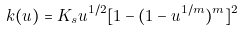<formula> <loc_0><loc_0><loc_500><loc_500>k ( u ) = K _ { s } u ^ { 1 / 2 } [ 1 - ( 1 - u ^ { 1 / m } ) ^ { m } ] ^ { 2 }</formula> 